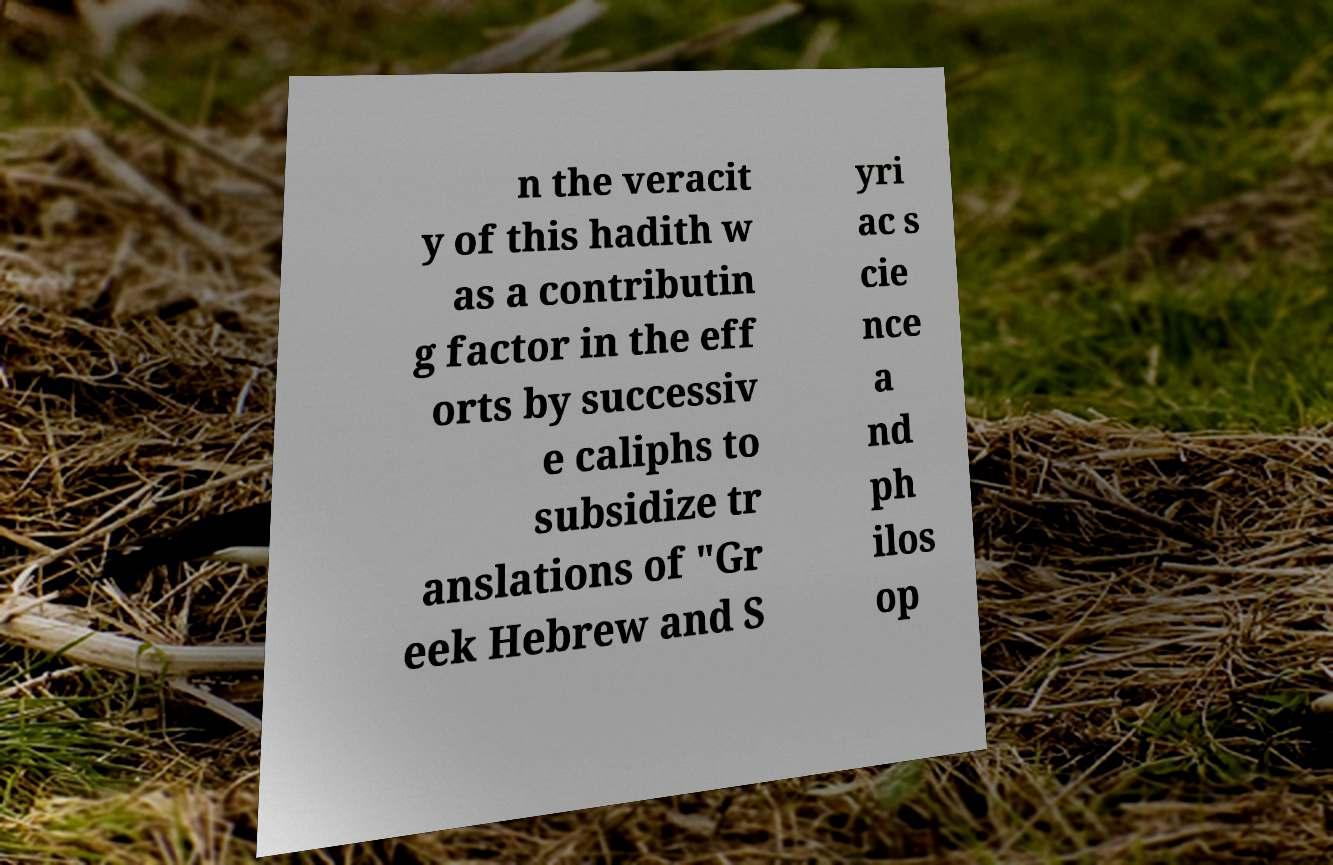Can you read and provide the text displayed in the image?This photo seems to have some interesting text. Can you extract and type it out for me? n the veracit y of this hadith w as a contributin g factor in the eff orts by successiv e caliphs to subsidize tr anslations of "Gr eek Hebrew and S yri ac s cie nce a nd ph ilos op 